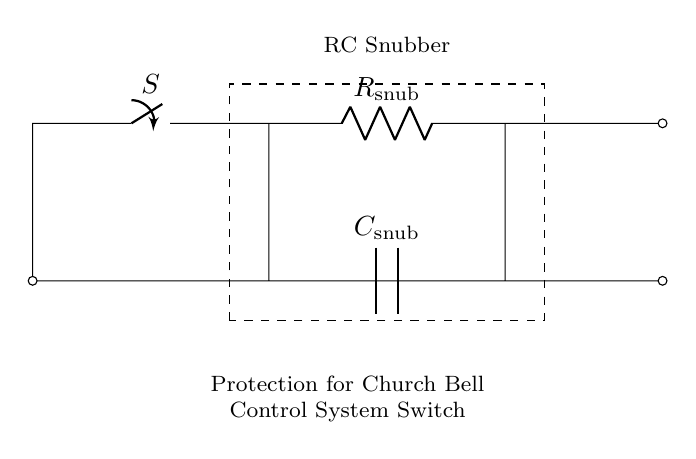What components are in this circuit? The circuit contains a switch (labeled S), a resistor (labeled R snub), and a capacitor (labeled C snub), all connected in a specific arrangement for an RC snubber circuit.
Answer: switch, resistor, capacitor What does the dashed rectangle represent? The dashed rectangle encloses the RC snubber circuit, indicating that all components within that box work together for a common function, specifically to protect the switch in the church bell control system.
Answer: RC Snubber Which component provides protection for the switch? The snubber circuit, consisting of the resistor and capacitor, collectively works to protect the switch from voltage spikes or transients that might occur when operating the bell control system.
Answer: resistor and capacitor How many terminal connections does the capacitor have? The capacitor has two terminal connections: one connected to the ground and the other connected to the resistor in the circuit. This configuration enables it to effectively store and release energy.
Answer: two What is the purpose of the resistor in the snubber circuit? The resistor limits the current flow during transient events, helping to dissipate energy and protect the switch from the effects of high voltage spikes, thereby maintaining the reliability of the circuit in the church bell control system.
Answer: limit current Why is this circuit classified as a resistor-capacitor circuit? This circuit is classified as a resistor-capacitor circuit because it contains both a resistor and a capacitor in conjunction, forming an RC combination that defines its characteristics, such as transient response and filtering behavior.
Answer: resistor and capacitor 